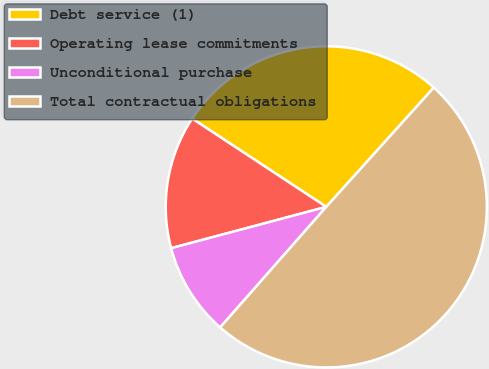Convert chart to OTSL. <chart><loc_0><loc_0><loc_500><loc_500><pie_chart><fcel>Debt service (1)<fcel>Operating lease commitments<fcel>Unconditional purchase<fcel>Total contractual obligations<nl><fcel>27.41%<fcel>13.41%<fcel>9.37%<fcel>49.81%<nl></chart> 